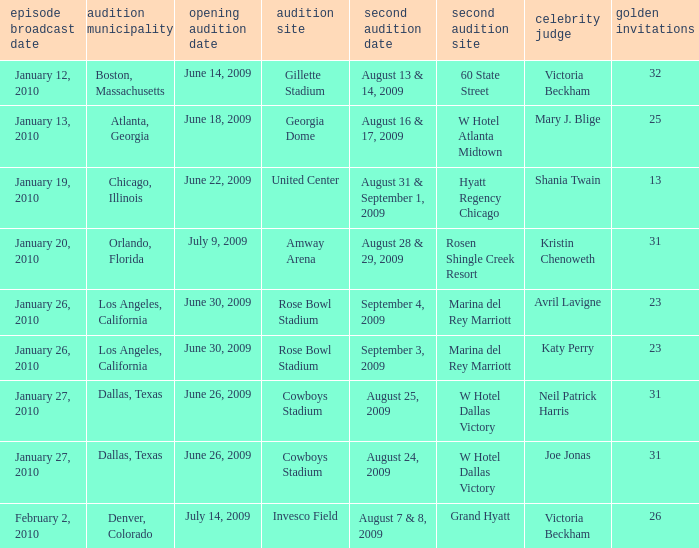Name the audition city for hyatt regency chicago Chicago, Illinois. Could you parse the entire table? {'header': ['episode broadcast date', 'audition municipality', 'opening audition date', 'audition site', 'second audition date', 'second audition site', 'celebrity judge', 'golden invitations'], 'rows': [['January 12, 2010', 'Boston, Massachusetts', 'June 14, 2009', 'Gillette Stadium', 'August 13 & 14, 2009', '60 State Street', 'Victoria Beckham', '32'], ['January 13, 2010', 'Atlanta, Georgia', 'June 18, 2009', 'Georgia Dome', 'August 16 & 17, 2009', 'W Hotel Atlanta Midtown', 'Mary J. Blige', '25'], ['January 19, 2010', 'Chicago, Illinois', 'June 22, 2009', 'United Center', 'August 31 & September 1, 2009', 'Hyatt Regency Chicago', 'Shania Twain', '13'], ['January 20, 2010', 'Orlando, Florida', 'July 9, 2009', 'Amway Arena', 'August 28 & 29, 2009', 'Rosen Shingle Creek Resort', 'Kristin Chenoweth', '31'], ['January 26, 2010', 'Los Angeles, California', 'June 30, 2009', 'Rose Bowl Stadium', 'September 4, 2009', 'Marina del Rey Marriott', 'Avril Lavigne', '23'], ['January 26, 2010', 'Los Angeles, California', 'June 30, 2009', 'Rose Bowl Stadium', 'September 3, 2009', 'Marina del Rey Marriott', 'Katy Perry', '23'], ['January 27, 2010', 'Dallas, Texas', 'June 26, 2009', 'Cowboys Stadium', 'August 25, 2009', 'W Hotel Dallas Victory', 'Neil Patrick Harris', '31'], ['January 27, 2010', 'Dallas, Texas', 'June 26, 2009', 'Cowboys Stadium', 'August 24, 2009', 'W Hotel Dallas Victory', 'Joe Jonas', '31'], ['February 2, 2010', 'Denver, Colorado', 'July 14, 2009', 'Invesco Field', 'August 7 & 8, 2009', 'Grand Hyatt', 'Victoria Beckham', '26']]} 